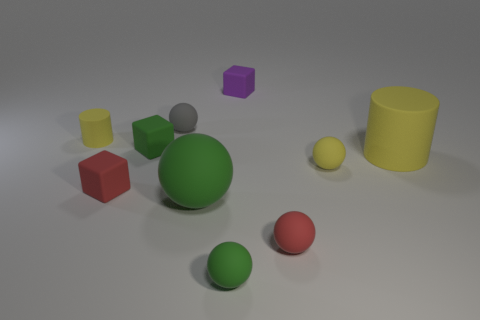Subtract all red cylinders. How many green spheres are left? 2 Subtract all tiny green spheres. How many spheres are left? 4 Subtract all gray spheres. How many spheres are left? 4 Subtract 3 spheres. How many spheres are left? 2 Subtract all cyan cubes. Subtract all blue spheres. How many cubes are left? 3 Add 7 tiny purple blocks. How many tiny purple blocks are left? 8 Add 6 small gray objects. How many small gray objects exist? 7 Subtract 0 blue blocks. How many objects are left? 10 Subtract all cylinders. How many objects are left? 8 Subtract all purple rubber objects. Subtract all large green balls. How many objects are left? 8 